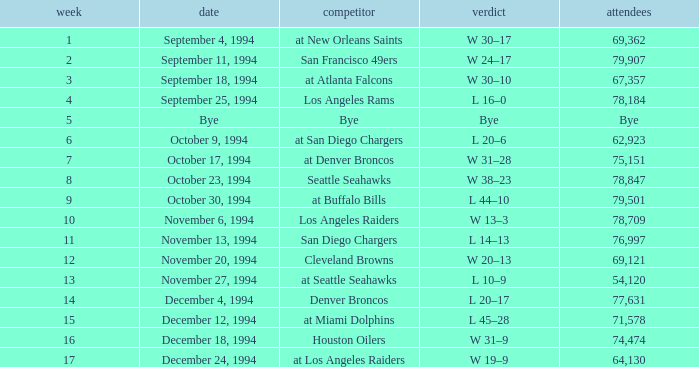Parse the table in full. {'header': ['week', 'date', 'competitor', 'verdict', 'attendees'], 'rows': [['1', 'September 4, 1994', 'at New Orleans Saints', 'W 30–17', '69,362'], ['2', 'September 11, 1994', 'San Francisco 49ers', 'W 24–17', '79,907'], ['3', 'September 18, 1994', 'at Atlanta Falcons', 'W 30–10', '67,357'], ['4', 'September 25, 1994', 'Los Angeles Rams', 'L 16–0', '78,184'], ['5', 'Bye', 'Bye', 'Bye', 'Bye'], ['6', 'October 9, 1994', 'at San Diego Chargers', 'L 20–6', '62,923'], ['7', 'October 17, 1994', 'at Denver Broncos', 'W 31–28', '75,151'], ['8', 'October 23, 1994', 'Seattle Seahawks', 'W 38–23', '78,847'], ['9', 'October 30, 1994', 'at Buffalo Bills', 'L 44–10', '79,501'], ['10', 'November 6, 1994', 'Los Angeles Raiders', 'W 13–3', '78,709'], ['11', 'November 13, 1994', 'San Diego Chargers', 'L 14–13', '76,997'], ['12', 'November 20, 1994', 'Cleveland Browns', 'W 20–13', '69,121'], ['13', 'November 27, 1994', 'at Seattle Seahawks', 'L 10–9', '54,120'], ['14', 'December 4, 1994', 'Denver Broncos', 'L 20–17', '77,631'], ['15', 'December 12, 1994', 'at Miami Dolphins', 'L 45–28', '71,578'], ['16', 'December 18, 1994', 'Houston Oilers', 'W 31–9', '74,474'], ['17', 'December 24, 1994', 'at Los Angeles Raiders', 'W 19–9', '64,130']]} What was the score of the Chiefs November 27, 1994 game? L 10–9. 